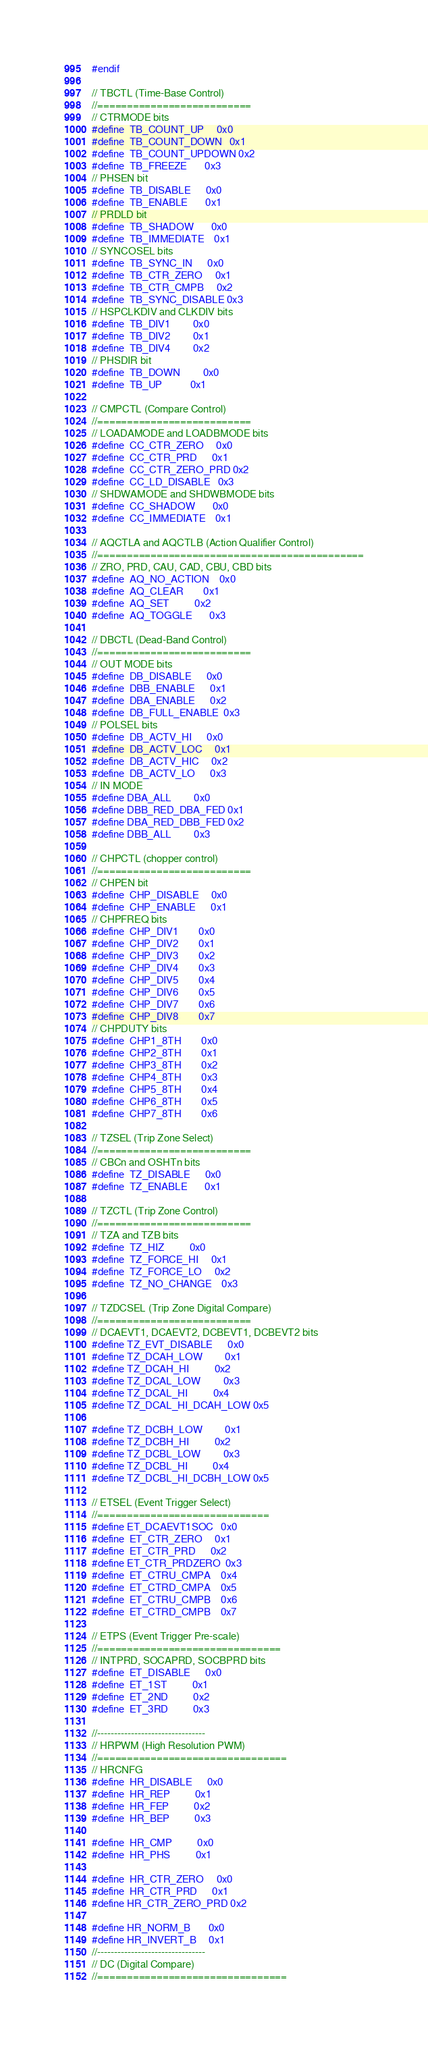Convert code to text. <code><loc_0><loc_0><loc_500><loc_500><_C_>#endif

// TBCTL (Time-Base Control)
//==========================
// CTRMODE bits
#define	TB_COUNT_UP		0x0
#define	TB_COUNT_DOWN	0x1
#define	TB_COUNT_UPDOWN	0x2
#define	TB_FREEZE		0x3
// PHSEN bit
#define	TB_DISABLE		0x0
#define	TB_ENABLE		0x1
// PRDLD bit
#define	TB_SHADOW		0x0
#define	TB_IMMEDIATE	0x1
// SYNCOSEL bits
#define	TB_SYNC_IN		0x0
#define	TB_CTR_ZERO		0x1
#define	TB_CTR_CMPB		0x2
#define	TB_SYNC_DISABLE	0x3
// HSPCLKDIV and CLKDIV bits
#define	TB_DIV1			0x0
#define	TB_DIV2			0x1
#define	TB_DIV4			0x2
// PHSDIR bit
#define	TB_DOWN			0x0
#define	TB_UP			0x1

// CMPCTL (Compare Control)
//==========================
// LOADAMODE and LOADBMODE bits
#define	CC_CTR_ZERO		0x0
#define	CC_CTR_PRD		0x1
#define	CC_CTR_ZERO_PRD	0x2
#define	CC_LD_DISABLE	0x3
// SHDWAMODE and SHDWBMODE bits
#define	CC_SHADOW		0x0
#define	CC_IMMEDIATE	0x1

// AQCTLA and AQCTLB (Action Qualifier Control)
//=============================================
// ZRO, PRD, CAU, CAD, CBU, CBD bits
#define	AQ_NO_ACTION	0x0
#define	AQ_CLEAR		0x1
#define	AQ_SET			0x2
#define	AQ_TOGGLE		0x3

// DBCTL (Dead-Band Control)
//==========================
// OUT MODE bits
#define	DB_DISABLE		0x0
#define	DBB_ENABLE		0x1
#define	DBA_ENABLE		0x2
#define	DB_FULL_ENABLE	0x3
// POLSEL bits
#define	DB_ACTV_HI		0x0
#define	DB_ACTV_LOC		0x1
#define	DB_ACTV_HIC		0x2
#define	DB_ACTV_LO		0x3
// IN MODE
#define DBA_ALL         0x0
#define DBB_RED_DBA_FED 0x1
#define DBA_RED_DBB_FED 0x2
#define DBB_ALL         0x3

// CHPCTL (chopper control)
//==========================
// CHPEN bit
#define	CHP_DISABLE		0x0
#define	CHP_ENABLE		0x1
// CHPFREQ bits
#define	CHP_DIV1		0x0
#define	CHP_DIV2		0x1
#define	CHP_DIV3		0x2
#define	CHP_DIV4		0x3
#define	CHP_DIV5		0x4
#define	CHP_DIV6		0x5
#define	CHP_DIV7		0x6
#define	CHP_DIV8		0x7
// CHPDUTY bits
#define	CHP1_8TH		0x0
#define	CHP2_8TH		0x1
#define	CHP3_8TH		0x2
#define	CHP4_8TH		0x3
#define	CHP5_8TH		0x4
#define	CHP6_8TH		0x5
#define	CHP7_8TH		0x6

// TZSEL (Trip Zone Select)
//==========================
// CBCn and OSHTn bits
#define	TZ_DISABLE		0x0
#define	TZ_ENABLE		0x1

// TZCTL (Trip Zone Control)
//==========================
// TZA and TZB bits
#define	TZ_HIZ			0x0
#define	TZ_FORCE_HI		0x1
#define	TZ_FORCE_LO		0x2
#define	TZ_NO_CHANGE	0x3

// TZDCSEL (Trip Zone Digital Compare)
//==========================
// DCAEVT1, DCAEVT2, DCBEVT1, DCBEVT2 bits
#define TZ_EVT_DISABLE      0x0
#define TZ_DCAH_LOW         0x1
#define TZ_DCAH_HI          0x2
#define TZ_DCAL_LOW         0x3
#define TZ_DCAL_HI          0x4
#define TZ_DCAL_HI_DCAH_LOW 0x5

#define TZ_DCBH_LOW         0x1
#define TZ_DCBH_HI          0x2
#define TZ_DCBL_LOW         0x3
#define TZ_DCBL_HI          0x4
#define TZ_DCBL_HI_DCBH_LOW 0x5

// ETSEL (Event Trigger Select)
//=============================
#define ET_DCAEVT1SOC   0x0
#define	ET_CTR_ZERO	    0x1
#define	ET_CTR_PRD	    0x2
#define ET_CTR_PRDZERO  0x3
#define	ET_CTRU_CMPA	0x4
#define	ET_CTRD_CMPA	0x5
#define	ET_CTRU_CMPB	0x6
#define	ET_CTRD_CMPB	0x7

// ETPS (Event Trigger Pre-scale)
//===============================
// INTPRD, SOCAPRD, SOCBPRD bits
#define	ET_DISABLE		0x0
#define	ET_1ST			0x1
#define	ET_2ND			0x2
#define	ET_3RD			0x3

//--------------------------------
// HRPWM (High Resolution PWM)
//================================
// HRCNFG
#define	HR_DISABLE		0x0
#define	HR_REP			0x1
#define	HR_FEP			0x2
#define	HR_BEP			0x3

#define	HR_CMP			0x0
#define	HR_PHS			0x1

#define	HR_CTR_ZERO		0x0
#define	HR_CTR_PRD		0x1
#define HR_CTR_ZERO_PRD 0x2

#define HR_NORM_B       0x0
#define HR_INVERT_B     0x1
//--------------------------------
// DC (Digital Compare)
//================================</code> 